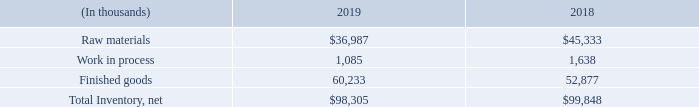Note 7 – Inventory
As of December 31, 2019 and 2018, inventory was comprised of the following:
Inventory reserves are established for estimated excess and obsolete inventory equal to the difference between the cost of the inventory and the estimated net realizable value of the inventory based on estimated reserve percentages, which consider historical usage, known trends, inventory age and market conditions. As of December 31, 2019 and 2018, our inventory reserve was $34.1 million and $30.0 million, respectively.
What was the inventory reserve in 2019? $34.1 million. What was the Raw material inventory in 2019?
Answer scale should be: thousand. 36,987. What was the work in process inventory in 2019?
Answer scale should be: thousand. 1,085. What was the change in raw materials between 2018 and 2019?
Answer scale should be: thousand. $36,987-$45,333
Answer: -8346. What was the change in finished goods between 2018 and 2019?
Answer scale should be: thousand. 60,233-52,877
Answer: 7356. What was the percentage change in net total inventory between 2018 and 2019?
Answer scale should be: percent. ($98,305-$99,848)/$99,848
Answer: -1.55. 